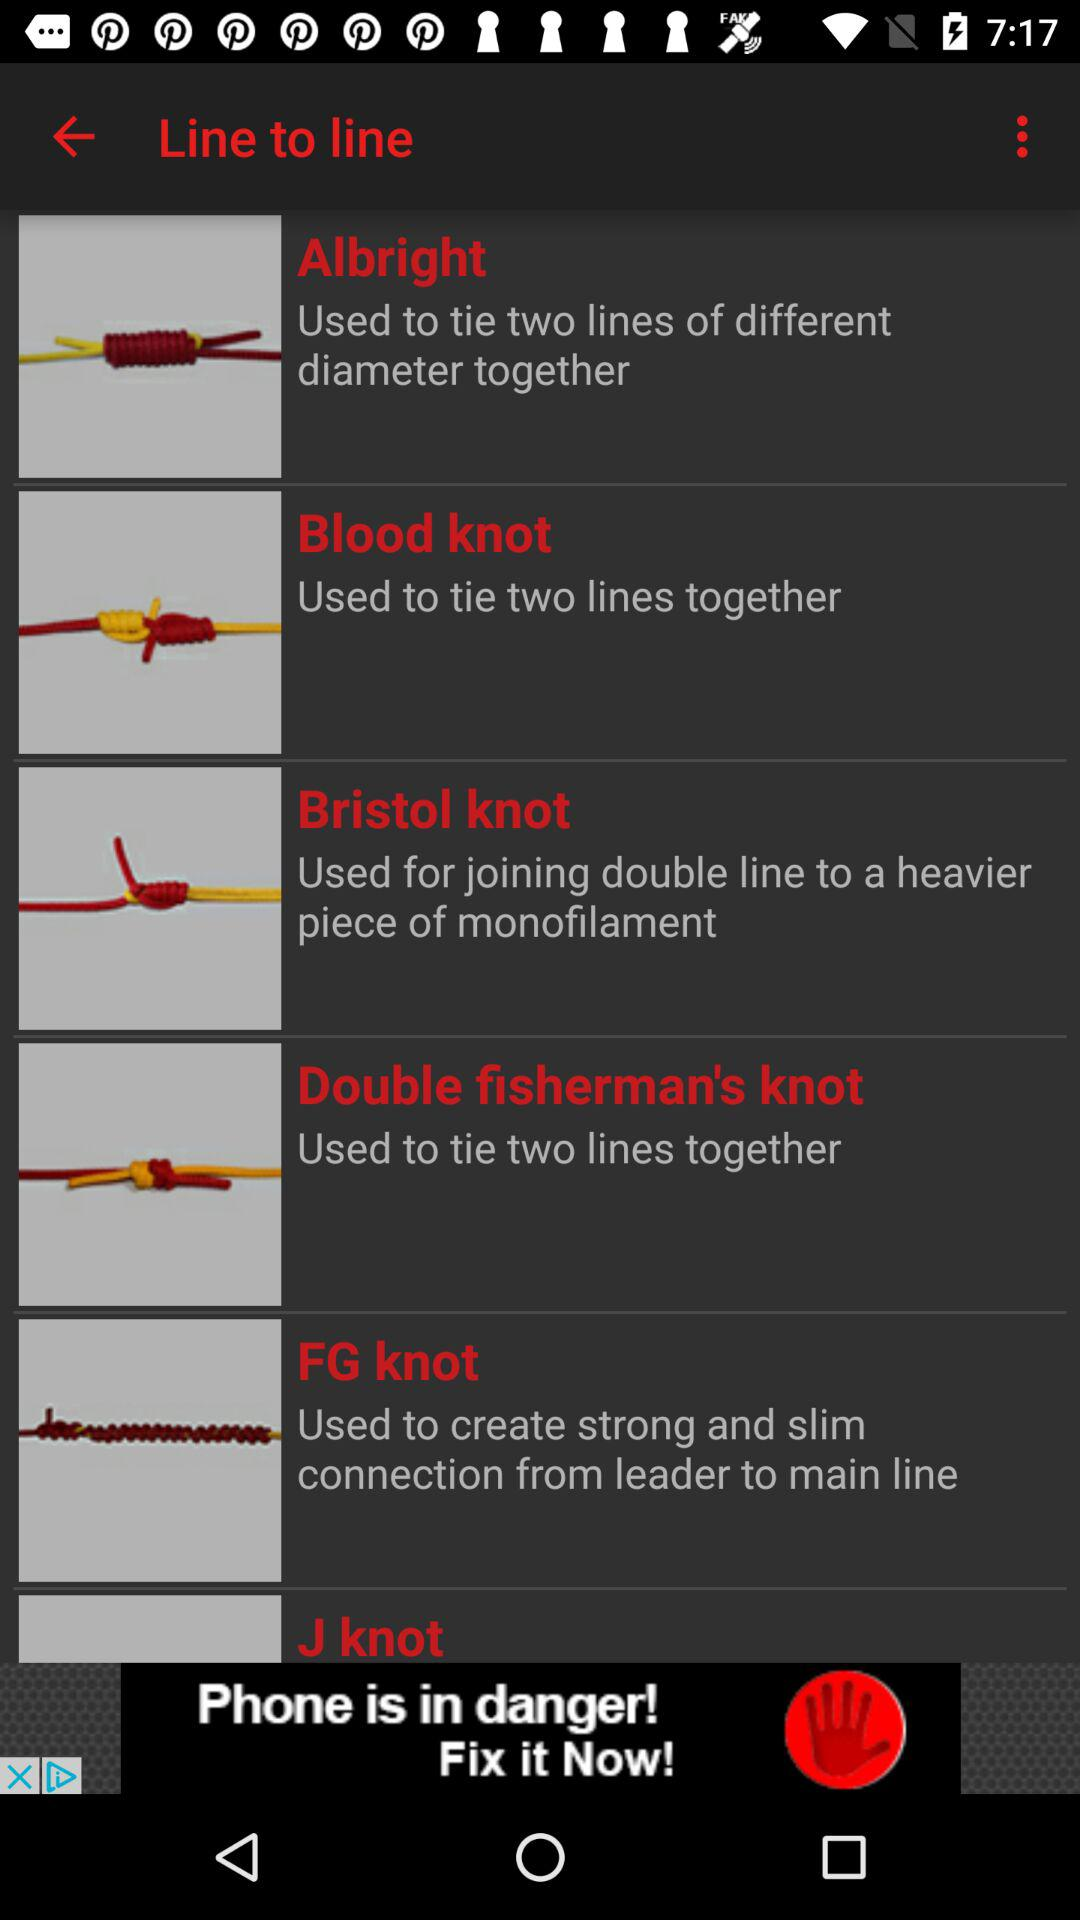How many knots are there with more than one line?
Answer the question using a single word or phrase. 5 